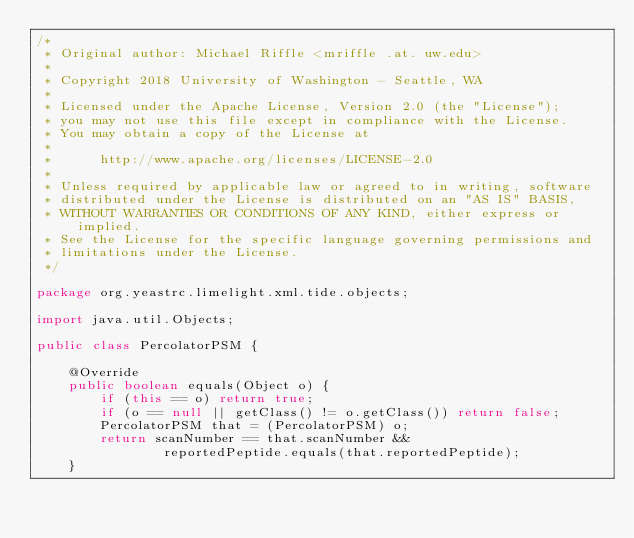<code> <loc_0><loc_0><loc_500><loc_500><_Java_>/*
 * Original author: Michael Riffle <mriffle .at. uw.edu>
 *                  
 * Copyright 2018 University of Washington - Seattle, WA
 *
 * Licensed under the Apache License, Version 2.0 (the "License");
 * you may not use this file except in compliance with the License.
 * You may obtain a copy of the License at
 *
 *      http://www.apache.org/licenses/LICENSE-2.0
 *
 * Unless required by applicable law or agreed to in writing, software
 * distributed under the License is distributed on an "AS IS" BASIS,
 * WITHOUT WARRANTIES OR CONDITIONS OF ANY KIND, either express or implied.
 * See the License for the specific language governing permissions and
 * limitations under the License.
 */

package org.yeastrc.limelight.xml.tide.objects;

import java.util.Objects;

public class PercolatorPSM {

	@Override
	public boolean equals(Object o) {
		if (this == o) return true;
		if (o == null || getClass() != o.getClass()) return false;
		PercolatorPSM that = (PercolatorPSM) o;
		return scanNumber == that.scanNumber &&
				reportedPeptide.equals(that.reportedPeptide);
	}
</code> 